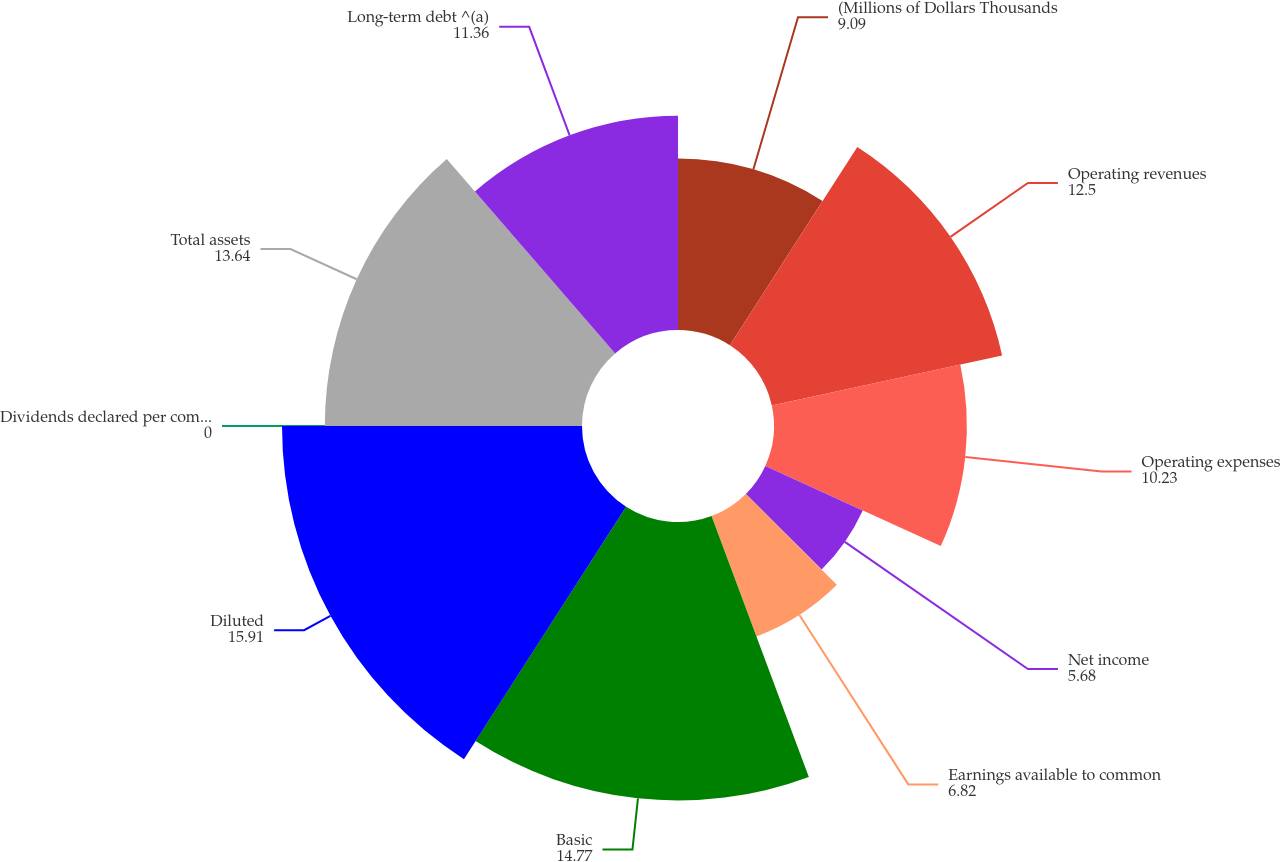<chart> <loc_0><loc_0><loc_500><loc_500><pie_chart><fcel>(Millions of Dollars Thousands<fcel>Operating revenues<fcel>Operating expenses<fcel>Net income<fcel>Earnings available to common<fcel>Basic<fcel>Diluted<fcel>Dividends declared per common<fcel>Total assets<fcel>Long-term debt ^(a)<nl><fcel>9.09%<fcel>12.5%<fcel>10.23%<fcel>5.68%<fcel>6.82%<fcel>14.77%<fcel>15.91%<fcel>0.0%<fcel>13.64%<fcel>11.36%<nl></chart> 